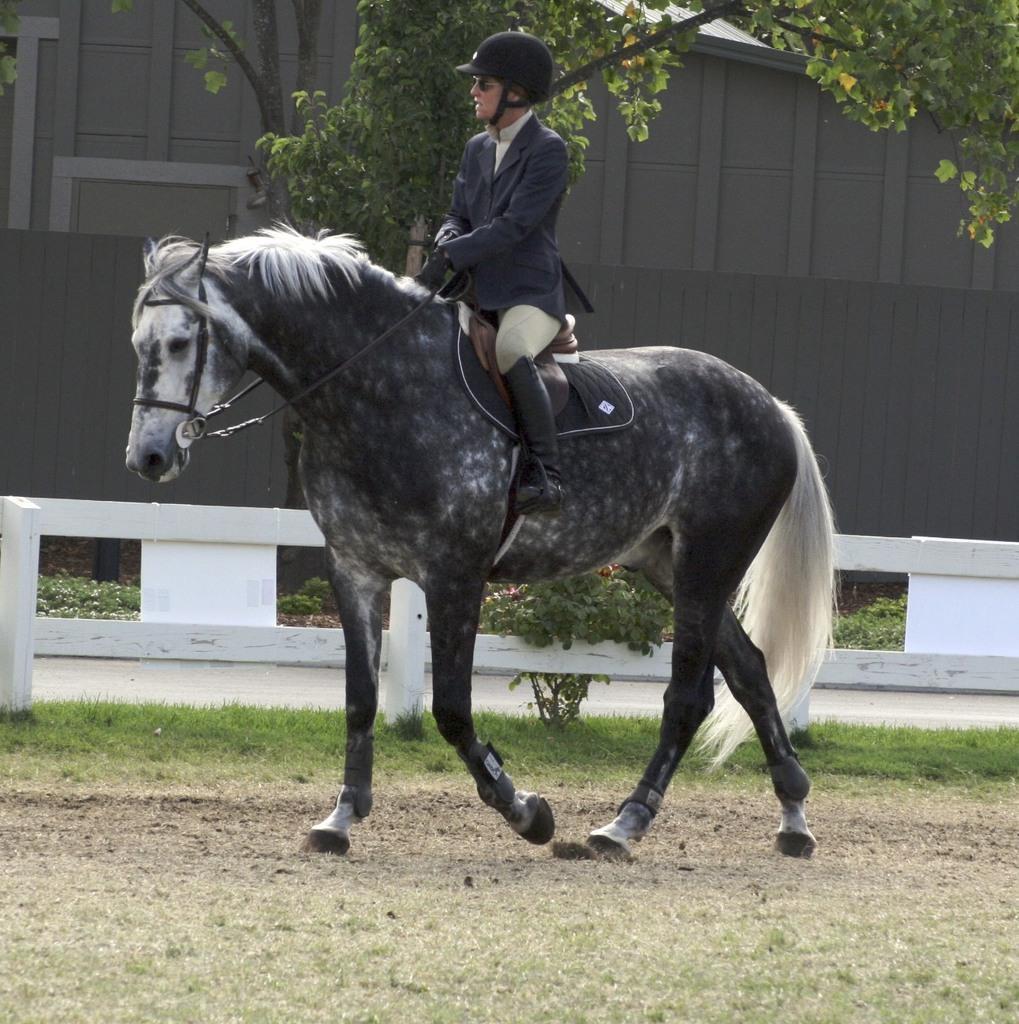In one or two sentences, can you explain what this image depicts? In the image we can see a person wearing clothes, boots, helmet and goggles, and the person is sitting on the horse, the horse is black and white in color. This is a grass, fence, building and a tree. 